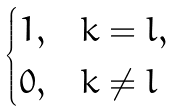<formula> <loc_0><loc_0><loc_500><loc_500>\begin{cases} 1 , & k = l , \\ 0 , & k \ne l \end{cases}</formula> 